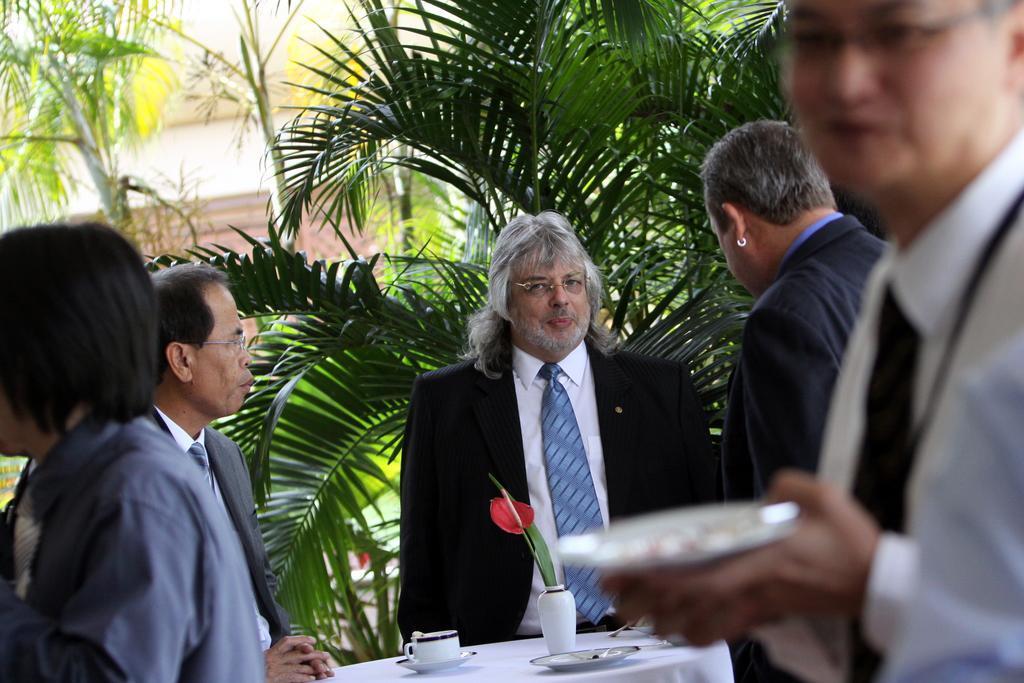Can you describe this image briefly? There is a man standing at the center. He is wearing a suit. There is another man on the right side. He is holding a plate in his hand. In the background there are trees. 